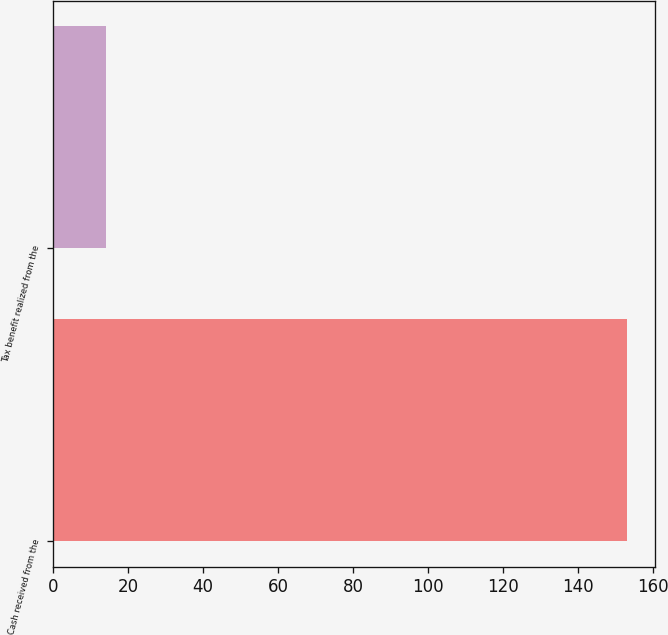Convert chart. <chart><loc_0><loc_0><loc_500><loc_500><bar_chart><fcel>Cash received from the<fcel>Tax benefit realized from the<nl><fcel>153<fcel>14<nl></chart> 